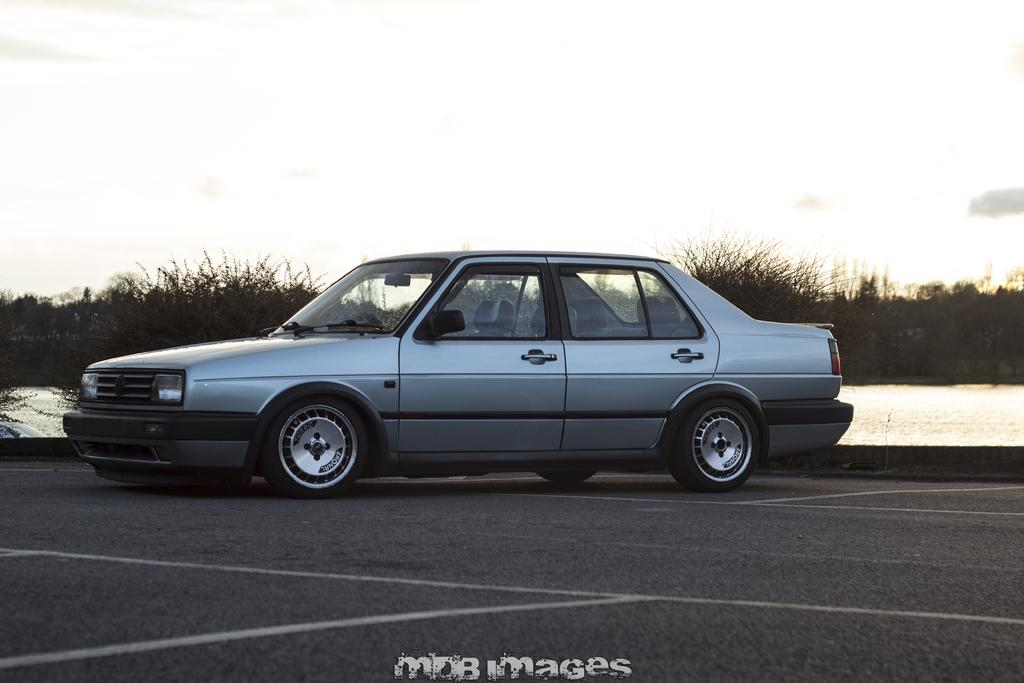What is the main subject of the image? The main subject of the image is a car. Where is the car located in the image? The car is on the road in the image. How is the car positioned in the picture? The car is in the middle of the picture. What can be seen in the background of the image? There are plants and the sky visible in the background of the image. What type of chair is the police officer sitting on in the image? There is no police officer or chair present in the image; it features a car on the road with plants and the sky in the background. 